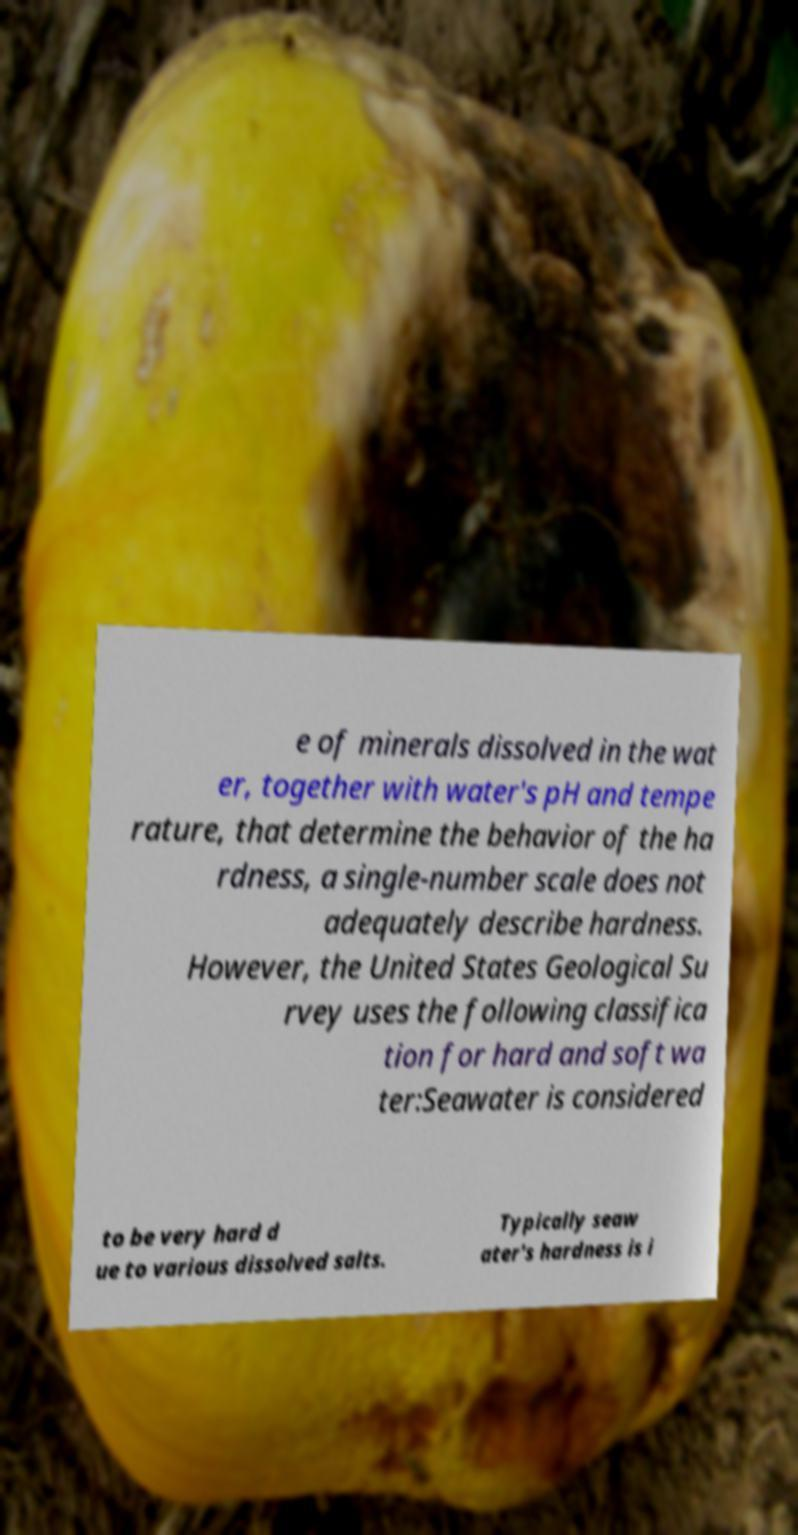I need the written content from this picture converted into text. Can you do that? e of minerals dissolved in the wat er, together with water's pH and tempe rature, that determine the behavior of the ha rdness, a single-number scale does not adequately describe hardness. However, the United States Geological Su rvey uses the following classifica tion for hard and soft wa ter:Seawater is considered to be very hard d ue to various dissolved salts. Typically seaw ater's hardness is i 